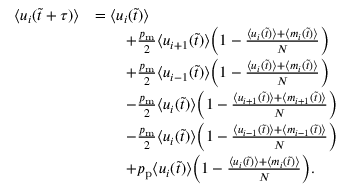Convert formula to latex. <formula><loc_0><loc_0><loc_500><loc_500>\begin{array} { r l } { \langle u _ { i } ( \tilde { t } + \tau ) \rangle } & { = \langle u _ { i } ( \tilde { t } ) \rangle } \\ & { \quad + \frac { p _ { m } } { 2 } \langle u _ { i + 1 } ( \tilde { t } ) \rangle \left ( 1 - \frac { \langle u _ { i } ( \tilde { t } ) \rangle + \langle m _ { i } ( \tilde { t } ) \rangle } { N } \right ) } \\ & { \quad + \frac { p _ { m } } { 2 } \langle u _ { i - 1 } ( \tilde { t } ) \rangle \left ( 1 - \frac { \langle u _ { i } ( \tilde { t } ) \rangle + \langle m _ { i } ( \tilde { t } ) \rangle } { N } \right ) } \\ & { \quad - \frac { p _ { m } } { 2 } \langle u _ { i } ( \tilde { t } ) \rangle \left ( 1 - \frac { \langle u _ { i + 1 } ( \tilde { t } ) \rangle + \langle m _ { i + 1 } ( \tilde { t } ) \rangle } { N } \right ) } \\ & { \quad - \frac { p _ { m } } { 2 } \langle u _ { i } ( \tilde { t } ) \rangle \left ( 1 - \frac { \langle u _ { i - 1 } ( \tilde { t } ) \rangle + \langle m _ { i - 1 } ( \tilde { t } ) \rangle } { N } \right ) } \\ & { \quad + p _ { p } \langle u _ { i } ( \tilde { t } ) \rangle \left ( 1 - \frac { \langle u _ { i } ( \tilde { t } ) \rangle + \langle m _ { i } ( \tilde { t } ) \rangle } { N } \right ) . } \end{array}</formula> 